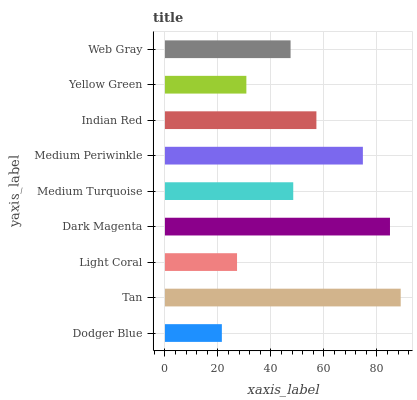Is Dodger Blue the minimum?
Answer yes or no. Yes. Is Tan the maximum?
Answer yes or no. Yes. Is Light Coral the minimum?
Answer yes or no. No. Is Light Coral the maximum?
Answer yes or no. No. Is Tan greater than Light Coral?
Answer yes or no. Yes. Is Light Coral less than Tan?
Answer yes or no. Yes. Is Light Coral greater than Tan?
Answer yes or no. No. Is Tan less than Light Coral?
Answer yes or no. No. Is Medium Turquoise the high median?
Answer yes or no. Yes. Is Medium Turquoise the low median?
Answer yes or no. Yes. Is Dodger Blue the high median?
Answer yes or no. No. Is Tan the low median?
Answer yes or no. No. 